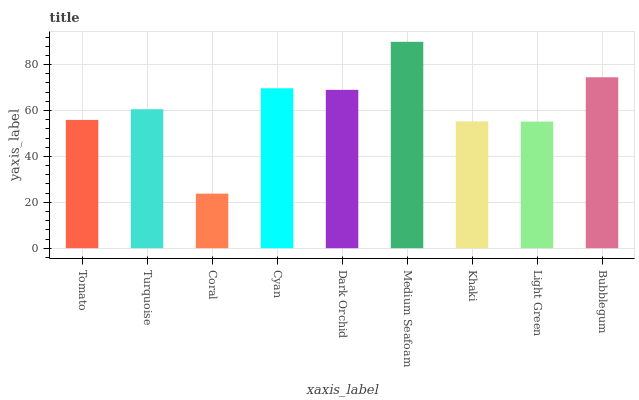Is Coral the minimum?
Answer yes or no. Yes. Is Medium Seafoam the maximum?
Answer yes or no. Yes. Is Turquoise the minimum?
Answer yes or no. No. Is Turquoise the maximum?
Answer yes or no. No. Is Turquoise greater than Tomato?
Answer yes or no. Yes. Is Tomato less than Turquoise?
Answer yes or no. Yes. Is Tomato greater than Turquoise?
Answer yes or no. No. Is Turquoise less than Tomato?
Answer yes or no. No. Is Turquoise the high median?
Answer yes or no. Yes. Is Turquoise the low median?
Answer yes or no. Yes. Is Bubblegum the high median?
Answer yes or no. No. Is Bubblegum the low median?
Answer yes or no. No. 